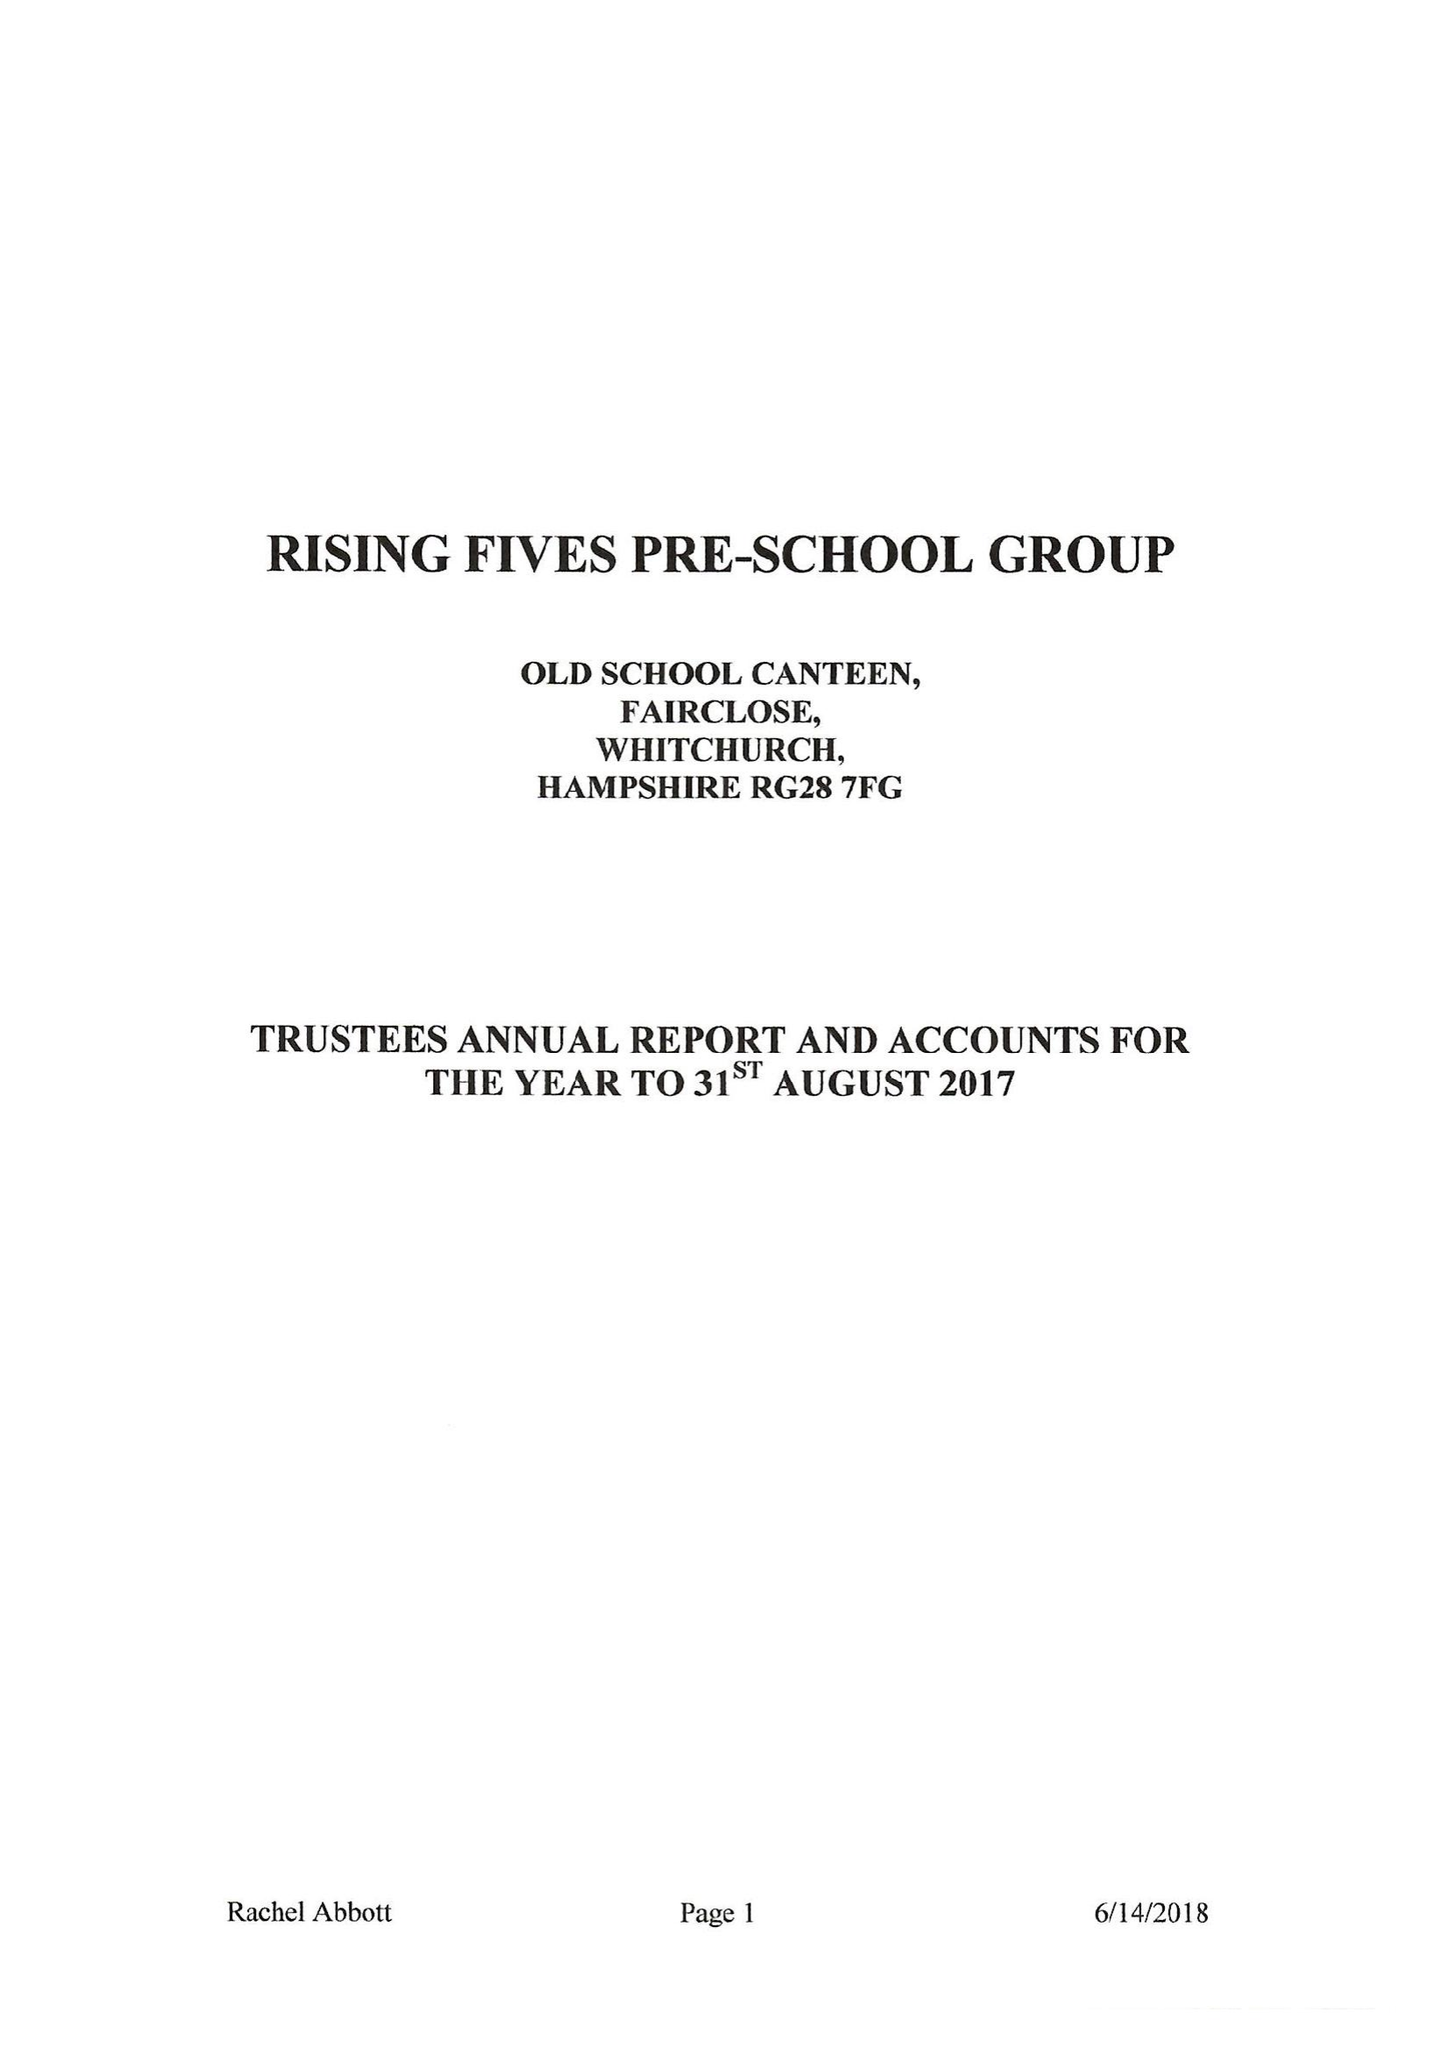What is the value for the address__street_line?
Answer the question using a single word or phrase. WELLS LANE 